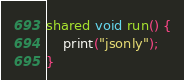<code> <loc_0><loc_0><loc_500><loc_500><_Ceylon_>
shared void run() {
    print("jsonly");
}
</code> 